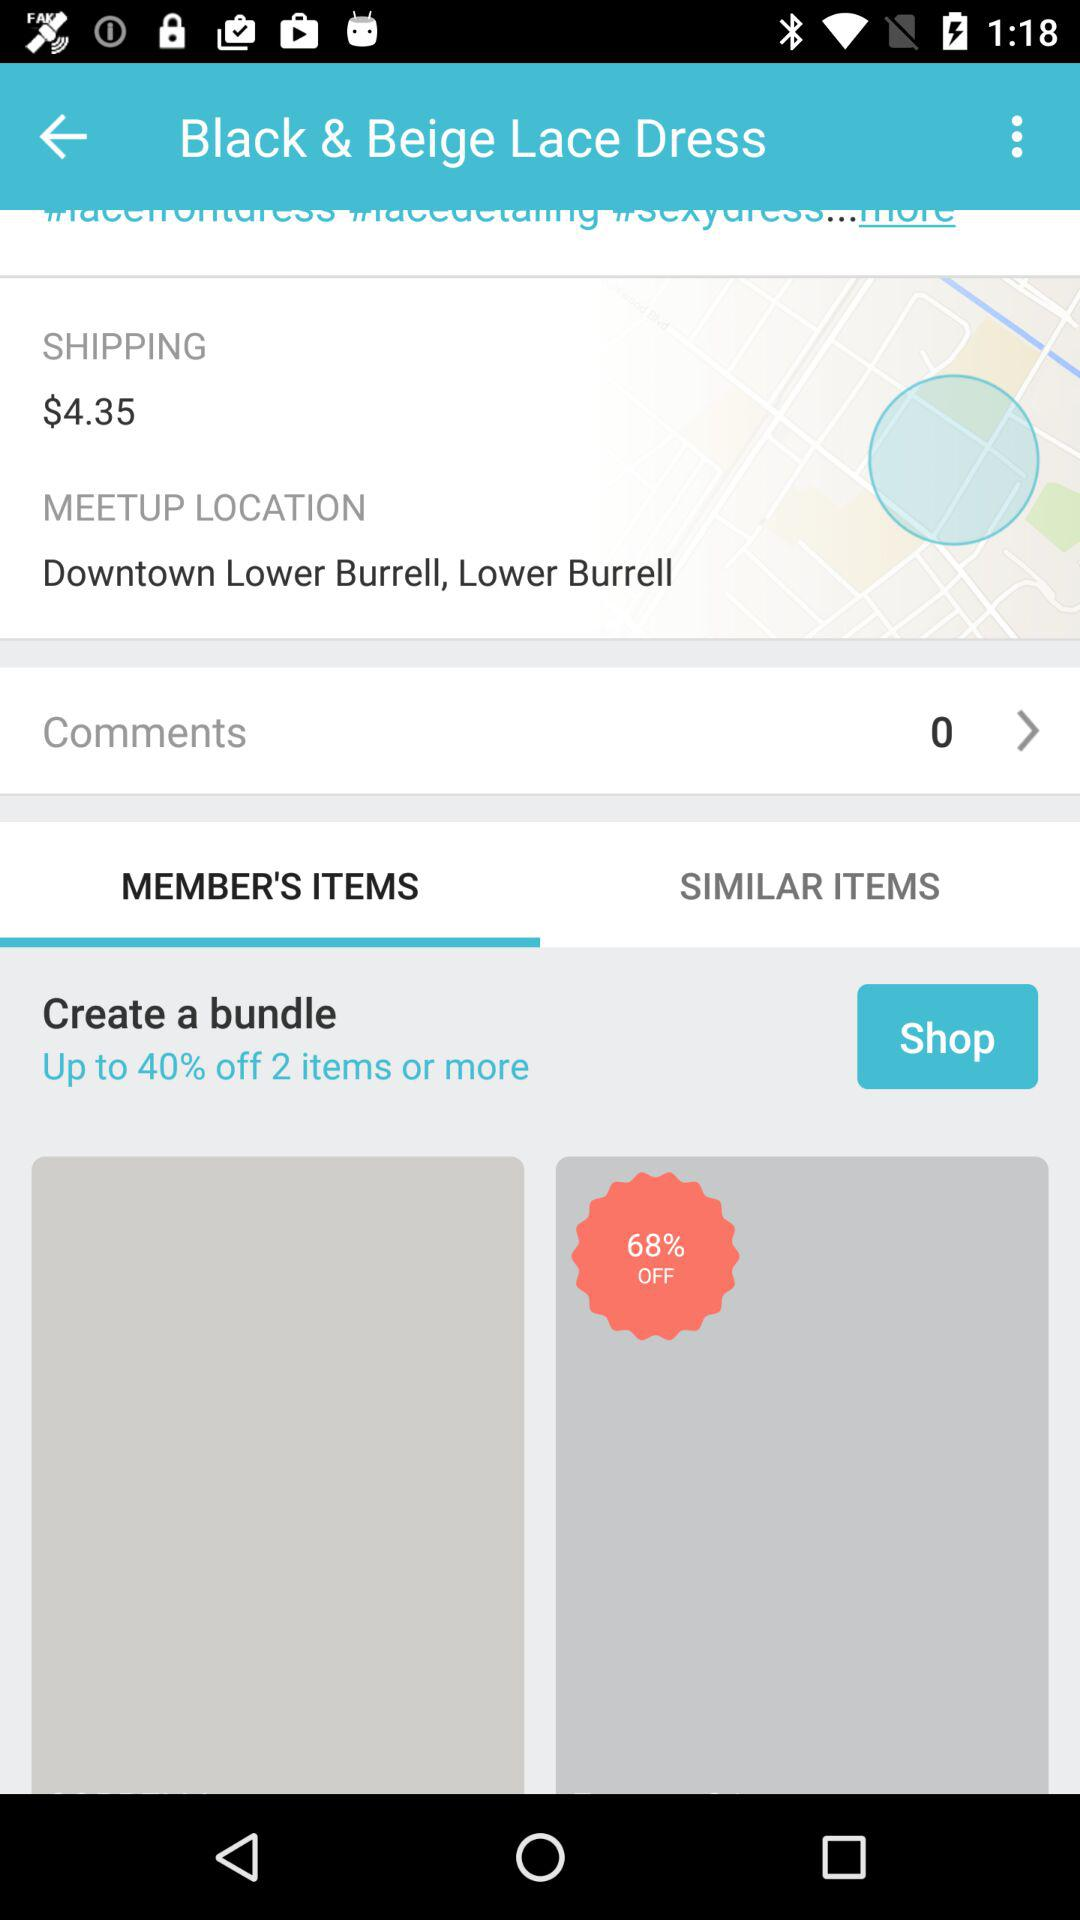What is the shipping cost? The shipping cost is $4.35. 